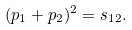Convert formula to latex. <formula><loc_0><loc_0><loc_500><loc_500>( p _ { 1 } + p _ { 2 } ) ^ { 2 } = s _ { 1 2 } .</formula> 